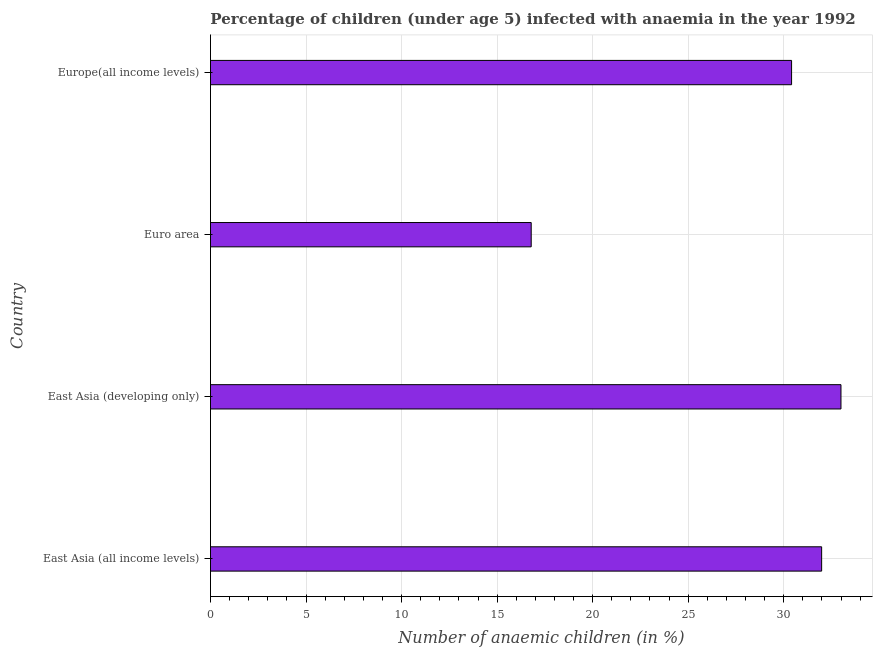Does the graph contain any zero values?
Offer a terse response. No. Does the graph contain grids?
Your answer should be very brief. Yes. What is the title of the graph?
Your response must be concise. Percentage of children (under age 5) infected with anaemia in the year 1992. What is the label or title of the X-axis?
Your answer should be compact. Number of anaemic children (in %). What is the label or title of the Y-axis?
Offer a terse response. Country. What is the number of anaemic children in Euro area?
Your response must be concise. 16.78. Across all countries, what is the maximum number of anaemic children?
Provide a short and direct response. 32.99. Across all countries, what is the minimum number of anaemic children?
Make the answer very short. 16.78. In which country was the number of anaemic children maximum?
Provide a succinct answer. East Asia (developing only). In which country was the number of anaemic children minimum?
Make the answer very short. Euro area. What is the sum of the number of anaemic children?
Keep it short and to the point. 112.17. What is the difference between the number of anaemic children in East Asia (all income levels) and Euro area?
Keep it short and to the point. 15.2. What is the average number of anaemic children per country?
Offer a terse response. 28.04. What is the median number of anaemic children?
Offer a terse response. 31.2. What is the difference between the highest and the lowest number of anaemic children?
Offer a very short reply. 16.21. How many bars are there?
Offer a very short reply. 4. How many countries are there in the graph?
Your answer should be compact. 4. What is the Number of anaemic children (in %) in East Asia (all income levels)?
Provide a short and direct response. 31.98. What is the Number of anaemic children (in %) of East Asia (developing only)?
Ensure brevity in your answer.  32.99. What is the Number of anaemic children (in %) of Euro area?
Offer a very short reply. 16.78. What is the Number of anaemic children (in %) of Europe(all income levels)?
Your response must be concise. 30.41. What is the difference between the Number of anaemic children (in %) in East Asia (all income levels) and East Asia (developing only)?
Keep it short and to the point. -1.01. What is the difference between the Number of anaemic children (in %) in East Asia (all income levels) and Euro area?
Offer a terse response. 15.2. What is the difference between the Number of anaemic children (in %) in East Asia (all income levels) and Europe(all income levels)?
Provide a succinct answer. 1.57. What is the difference between the Number of anaemic children (in %) in East Asia (developing only) and Euro area?
Keep it short and to the point. 16.21. What is the difference between the Number of anaemic children (in %) in East Asia (developing only) and Europe(all income levels)?
Provide a succinct answer. 2.58. What is the difference between the Number of anaemic children (in %) in Euro area and Europe(all income levels)?
Your answer should be very brief. -13.63. What is the ratio of the Number of anaemic children (in %) in East Asia (all income levels) to that in East Asia (developing only)?
Keep it short and to the point. 0.97. What is the ratio of the Number of anaemic children (in %) in East Asia (all income levels) to that in Euro area?
Your response must be concise. 1.91. What is the ratio of the Number of anaemic children (in %) in East Asia (all income levels) to that in Europe(all income levels)?
Provide a succinct answer. 1.05. What is the ratio of the Number of anaemic children (in %) in East Asia (developing only) to that in Euro area?
Offer a terse response. 1.97. What is the ratio of the Number of anaemic children (in %) in East Asia (developing only) to that in Europe(all income levels)?
Ensure brevity in your answer.  1.08. What is the ratio of the Number of anaemic children (in %) in Euro area to that in Europe(all income levels)?
Your answer should be compact. 0.55. 